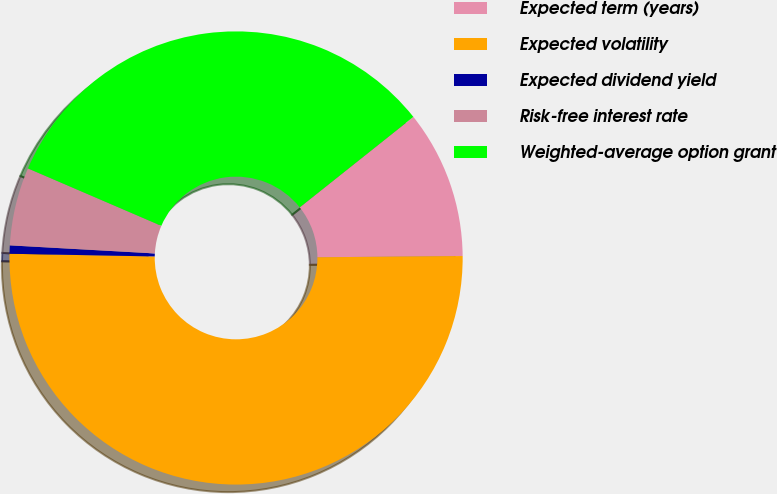Convert chart to OTSL. <chart><loc_0><loc_0><loc_500><loc_500><pie_chart><fcel>Expected term (years)<fcel>Expected volatility<fcel>Expected dividend yield<fcel>Risk-free interest rate<fcel>Weighted-average option grant<nl><fcel>10.56%<fcel>50.43%<fcel>0.59%<fcel>5.58%<fcel>32.83%<nl></chart> 